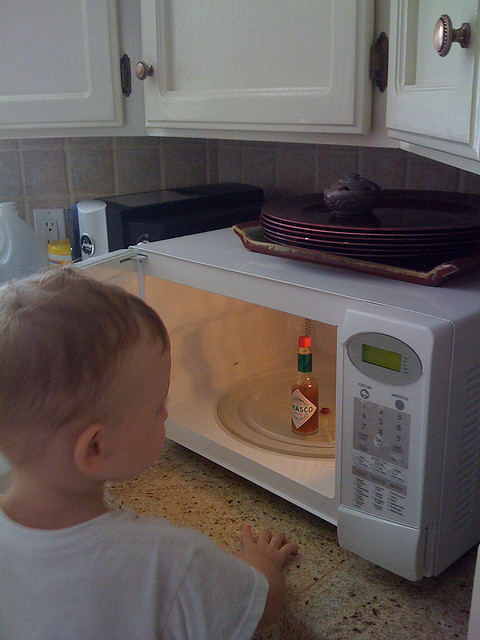<image>What is the thing on top of the fridge? It is ambiguous what is on top of the fridge because the fridge is not visible in the image. What is the thing on top of the fridge? I don't know what is the thing on top of the fridge. It can be plates, dish or microwave. 